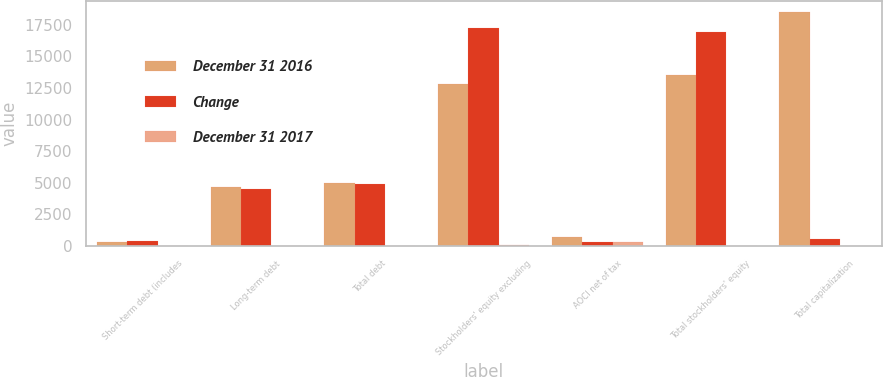<chart> <loc_0><loc_0><loc_500><loc_500><stacked_bar_chart><ecel><fcel>Short-term debt (includes<fcel>Long-term debt<fcel>Total debt<fcel>Stockholders' equity excluding<fcel>AOCI net of tax<fcel>Total stockholders' equity<fcel>Total capitalization<nl><fcel>December 31 2016<fcel>320<fcel>4678<fcel>4998<fcel>12831<fcel>663<fcel>13494<fcel>18492<nl><fcel>Change<fcel>416<fcel>4493<fcel>4909<fcel>17240<fcel>337<fcel>16903<fcel>539.5<nl><fcel>December 31 2017<fcel>23<fcel>4<fcel>2<fcel>26<fcel>297<fcel>20<fcel>15<nl></chart> 